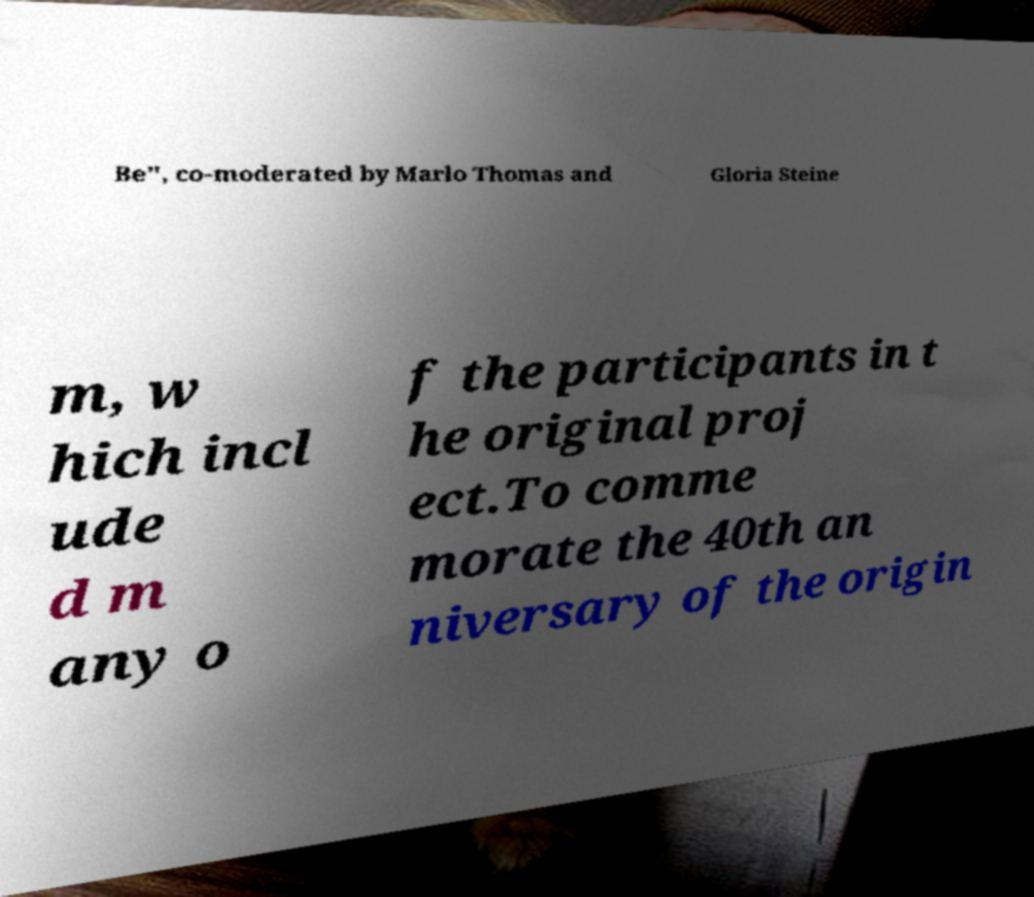I need the written content from this picture converted into text. Can you do that? Be", co-moderated by Marlo Thomas and Gloria Steine m, w hich incl ude d m any o f the participants in t he original proj ect.To comme morate the 40th an niversary of the origin 